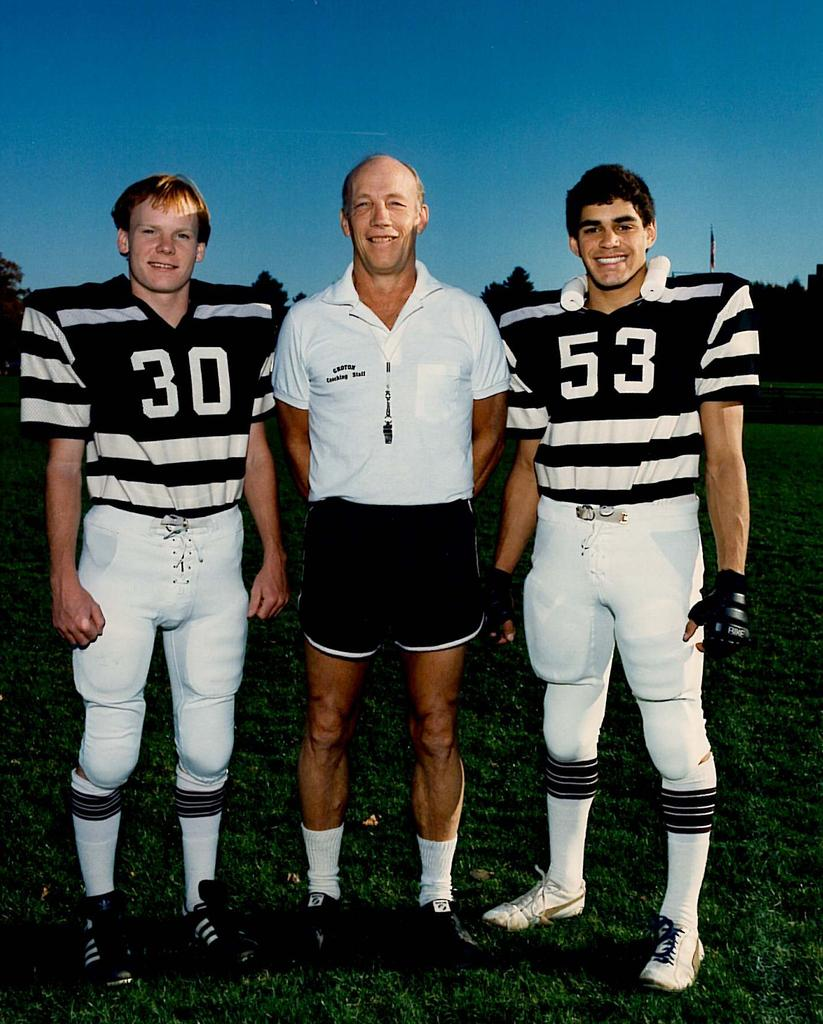What is the surface that the people are standing on in the image? The people are standing on the grass. What can be seen in the background of the image? There are trees visible in the background. What type of jewel is being worn by the trees in the background? There are no jewels present in the image, as the trees are natural elements and do not wear jewelry. 